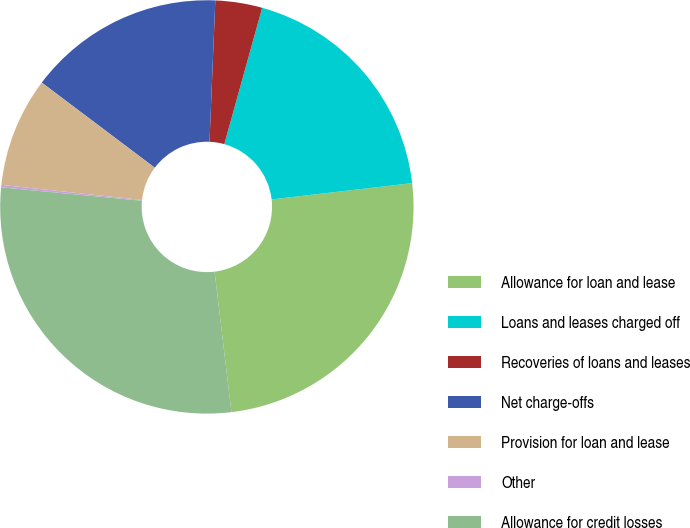<chart> <loc_0><loc_0><loc_500><loc_500><pie_chart><fcel>Allowance for loan and lease<fcel>Loans and leases charged off<fcel>Recoveries of loans and leases<fcel>Net charge-offs<fcel>Provision for loan and lease<fcel>Other<fcel>Allowance for credit losses<nl><fcel>24.94%<fcel>18.85%<fcel>3.66%<fcel>15.38%<fcel>8.57%<fcel>0.19%<fcel>28.41%<nl></chart> 